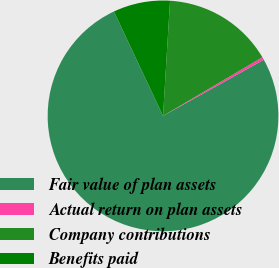Convert chart. <chart><loc_0><loc_0><loc_500><loc_500><pie_chart><fcel>Fair value of plan assets<fcel>Actual return on plan assets<fcel>Company contributions<fcel>Benefits paid<nl><fcel>76.1%<fcel>0.4%<fcel>15.54%<fcel>7.97%<nl></chart> 